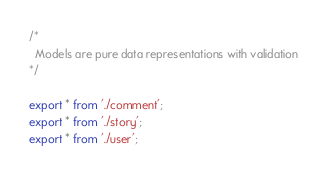Convert code to text. <code><loc_0><loc_0><loc_500><loc_500><_TypeScript_>/*
  Models are pure data representations with validation
*/

export * from './comment';
export * from './story';
export * from './user';
</code> 